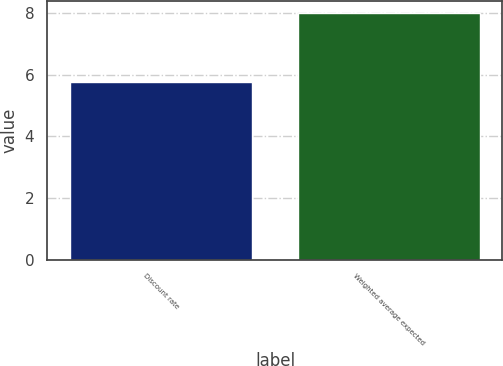Convert chart. <chart><loc_0><loc_0><loc_500><loc_500><bar_chart><fcel>Discount rate<fcel>Weighted average expected<nl><fcel>5.75<fcel>8<nl></chart> 